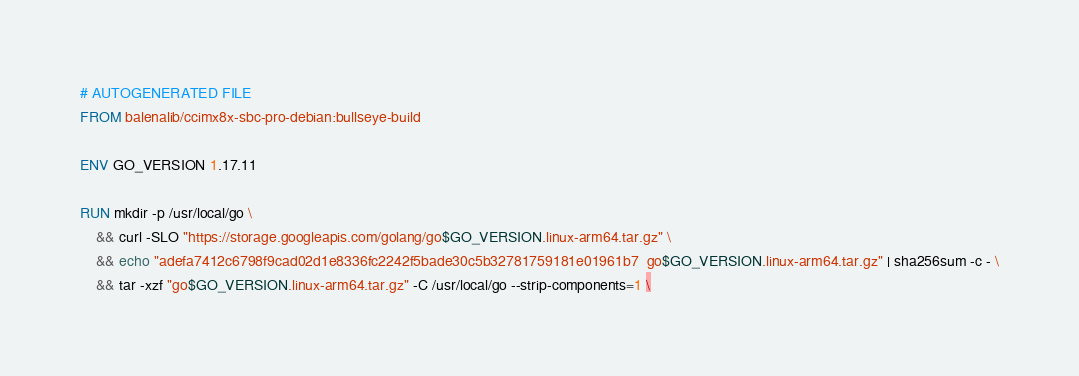<code> <loc_0><loc_0><loc_500><loc_500><_Dockerfile_># AUTOGENERATED FILE
FROM balenalib/ccimx8x-sbc-pro-debian:bullseye-build

ENV GO_VERSION 1.17.11

RUN mkdir -p /usr/local/go \
	&& curl -SLO "https://storage.googleapis.com/golang/go$GO_VERSION.linux-arm64.tar.gz" \
	&& echo "adefa7412c6798f9cad02d1e8336fc2242f5bade30c5b32781759181e01961b7  go$GO_VERSION.linux-arm64.tar.gz" | sha256sum -c - \
	&& tar -xzf "go$GO_VERSION.linux-arm64.tar.gz" -C /usr/local/go --strip-components=1 \</code> 